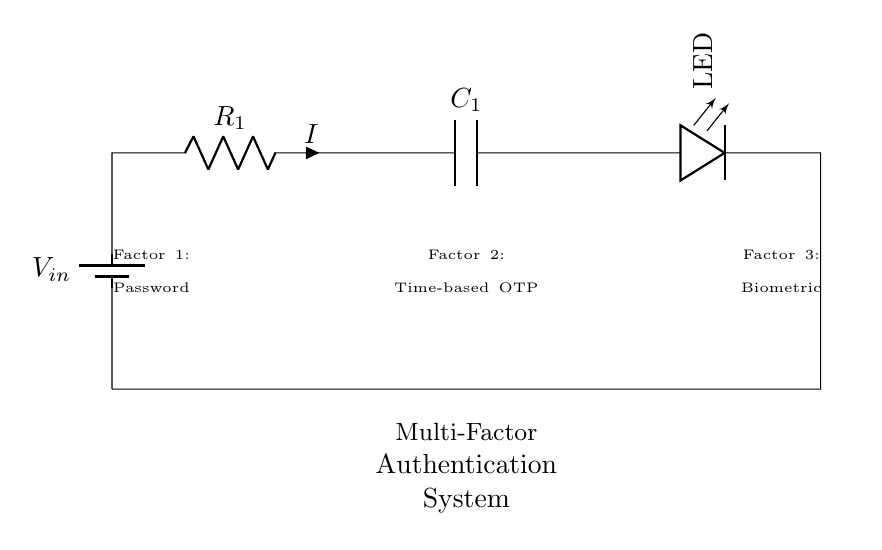What is the first component in the circuit? The first component in the circuit is a battery, which provides the input voltage for the circuit.
Answer: Battery What does the resistor represent in this circuit? The resistor is used to limit the current flowing through the circuit, ensuring that the LED receives an appropriate level of current to function correctly without burning out.
Answer: Current limiter What is the purpose of the capacitor in this circuit? The capacitor in this circuit serves to filter noise or stabilize voltage levels, contributing to the overall reliability of the authentication system by smoothing out fluctuations in the input voltage.
Answer: Stabilization How many factors are shown in the multi-factor authentication system? There are three factors shown: Password, Time-based OTP, and Biometric. These represent the different layers of security required for authentication.
Answer: Three What is the current flow direction in this series circuit? The current flows from the positive terminal of the battery through the resistor, then the capacitor, and finally through the LED before returning to the battery's negative terminal.
Answer: Clockwise What happens to the LED when the circuit is powered on? When the circuit is powered on, the LED will illuminate if the voltage and current are within acceptable levels, indicating that power is flowing through the circuit and the authentication factors are being evaluated.
Answer: LED illuminates What type of circuit is this? This is a series circuit, as all components are connected end-to-end in a single path, allowing the same current to flow through each component.
Answer: Series 